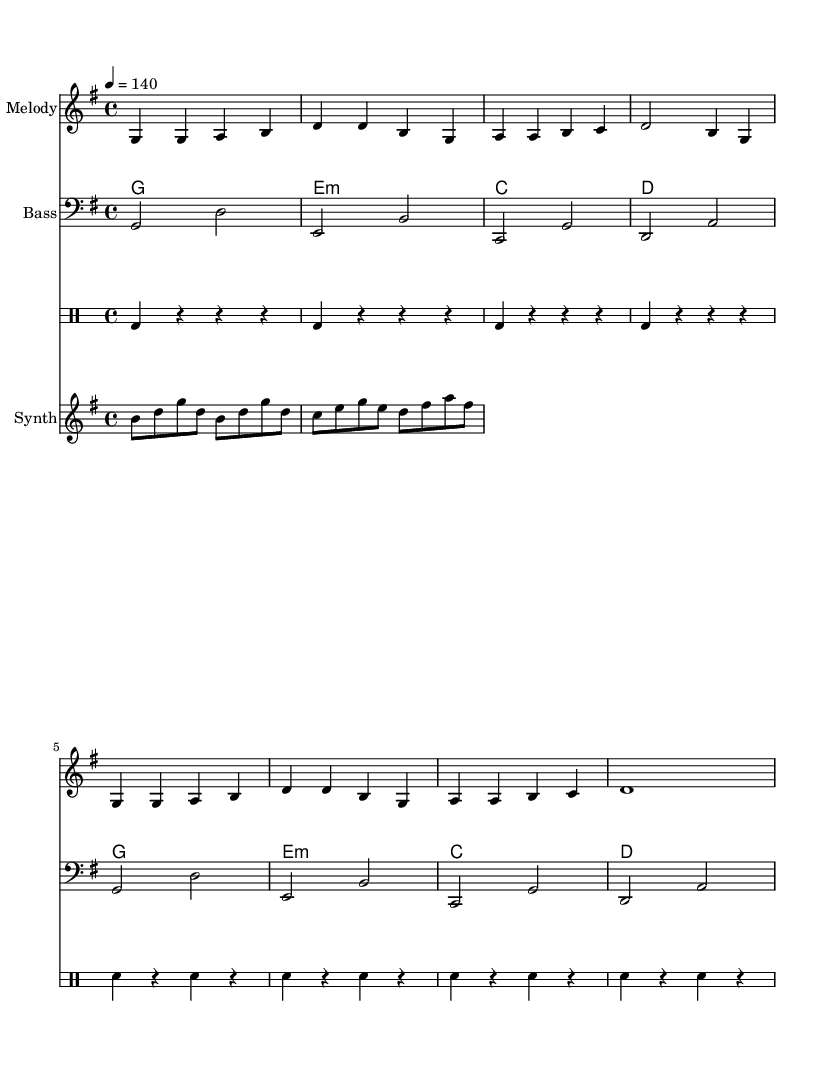What is the key signature of this music? The key signature indicated in the music is G major, which features one sharp (F#).
Answer: G major What is the time signature of this piece? The time signature shown in the music is 4/4, meaning there are four beats in each measure.
Answer: 4/4 What is the tempo marking for this music? The tempo marking specified at the beginning is 4 = 140, indicating a quarter-note gets 140 beats per minute.
Answer: 140 How many measures are in the melody section? The melody section contains a total of 8 measures, counted visually from the notation.
Answer: 8 What type of instruments are indicated in this score? The score lists a melody, bass, drum staff, and synth, which are common in K-Pop arrangements.
Answer: Melody, Bass, Drum Staff, Synth How many times does the chord for G major appear in the chord section? The G major chord appears twice in the chord progression, accounting for its repetitions in the melody.
Answer: 2 What lyrical theme is present in this K-Pop song? The lyrics emphasize teamwork and striving for victory, which is a common theme in energetic K-Pop tracks intended for team bonding and motivation.
Answer: Teamwork and victory 